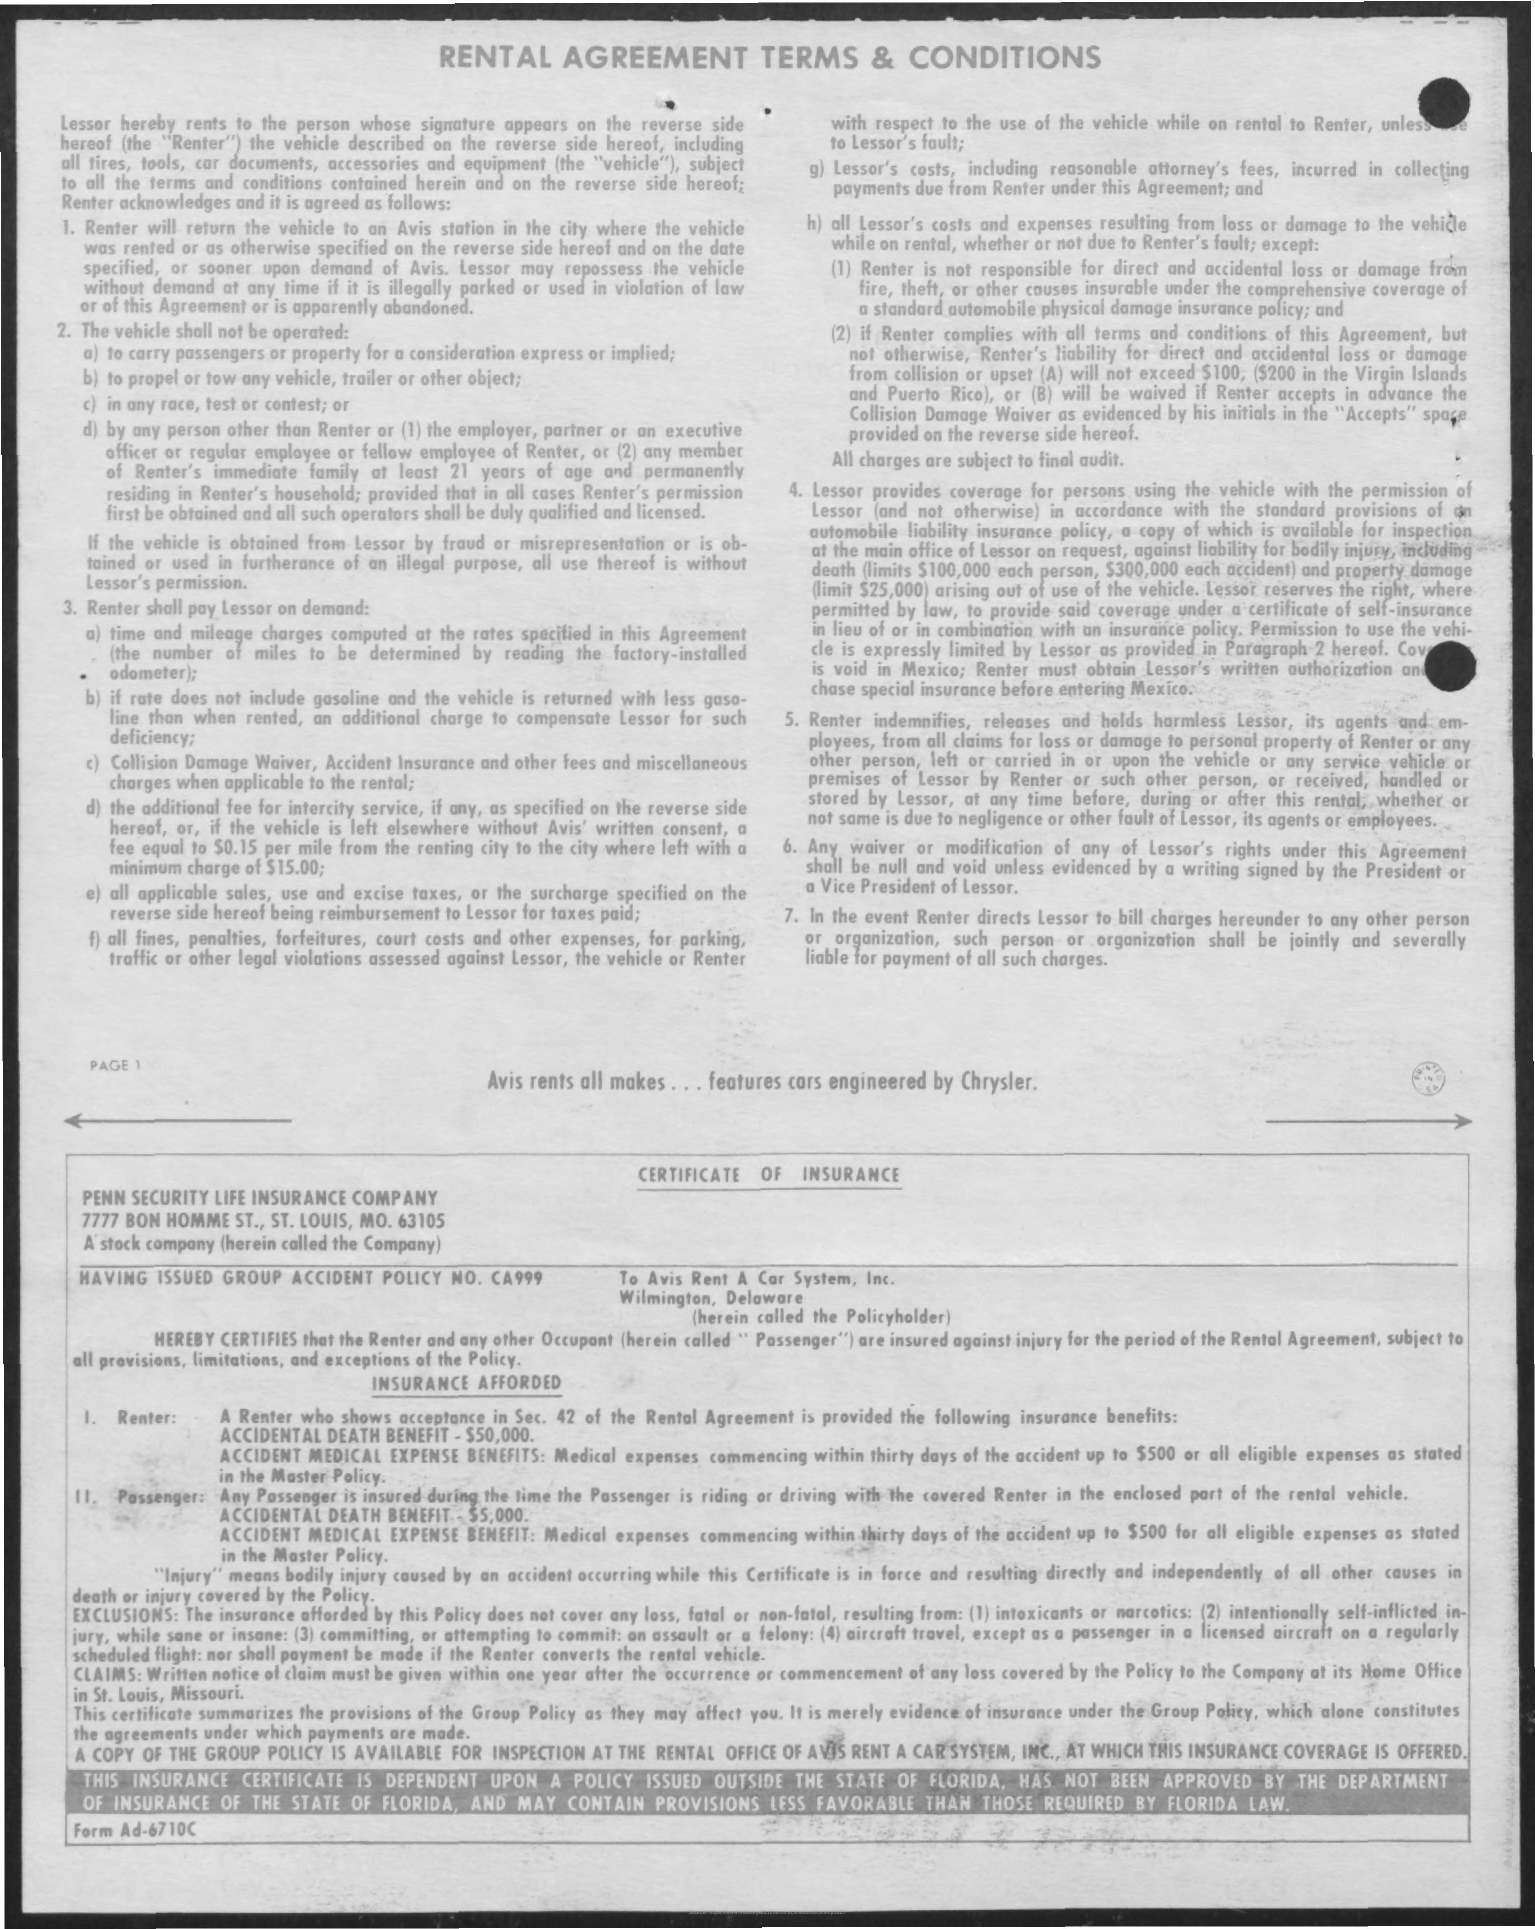What is the title of the document?
Your response must be concise. Rental Agreement Terms & Conditions. 